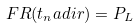<formula> <loc_0><loc_0><loc_500><loc_500>F R ( t _ { n } a d i r ) = P _ { L }</formula> 